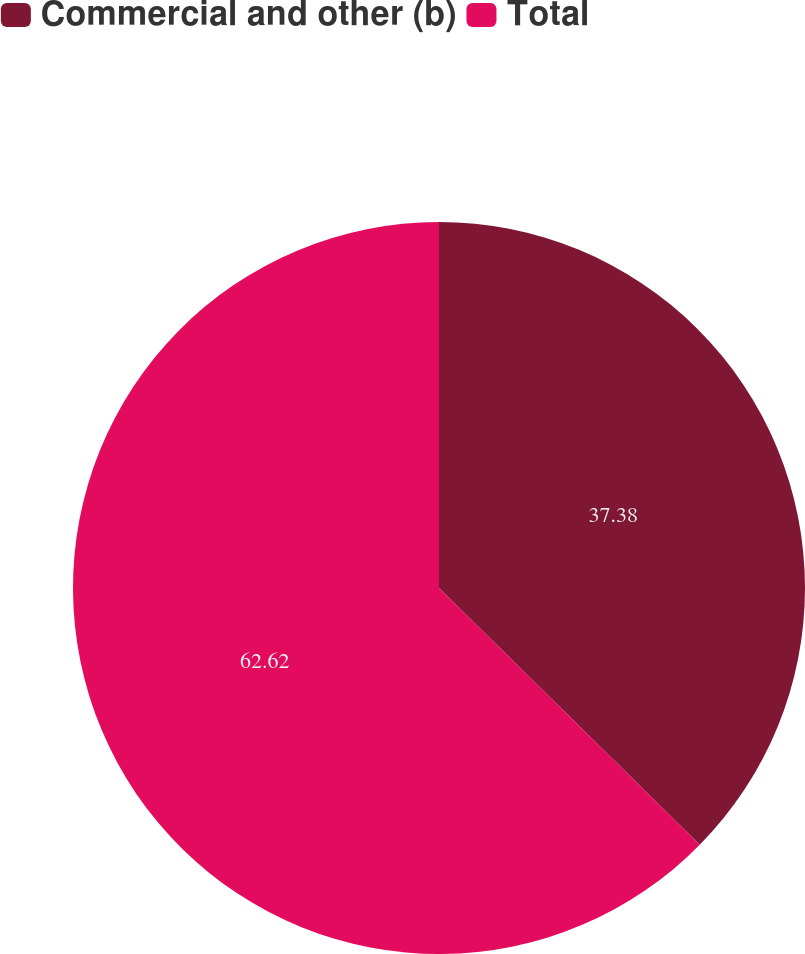Convert chart. <chart><loc_0><loc_0><loc_500><loc_500><pie_chart><fcel>Commercial and other (b)<fcel>Total<nl><fcel>37.38%<fcel>62.62%<nl></chart> 